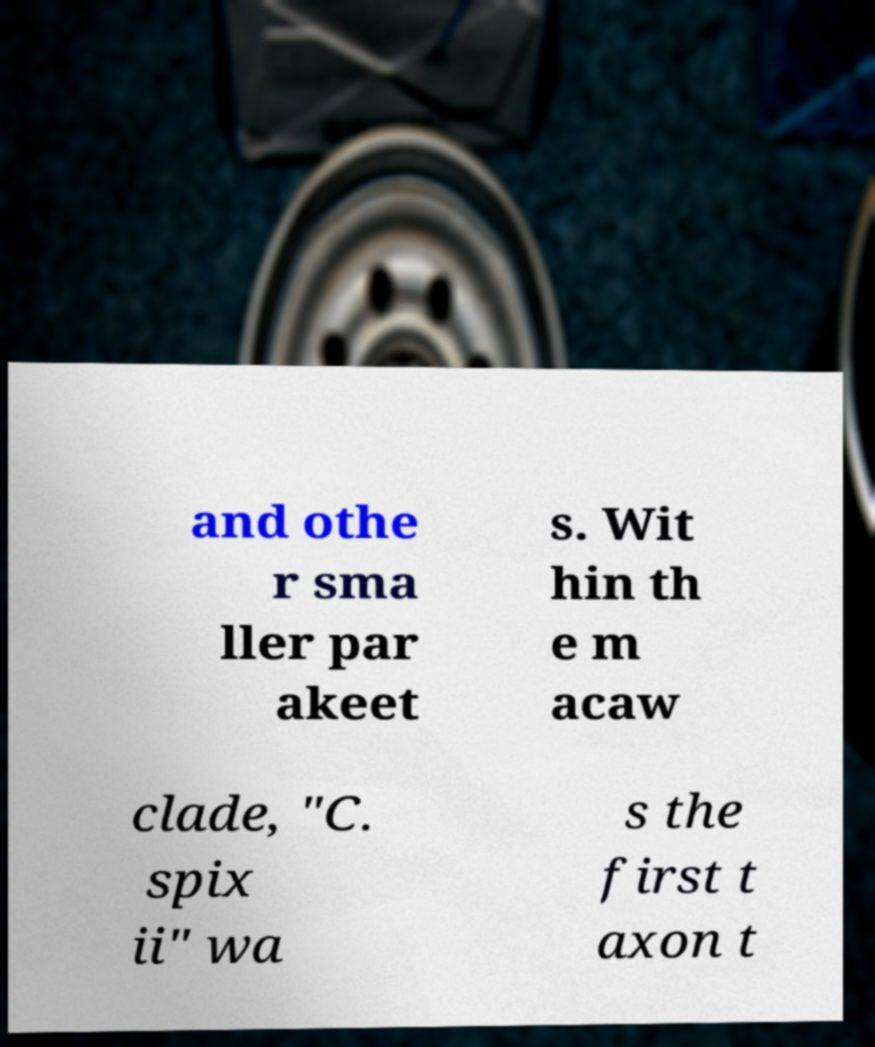I need the written content from this picture converted into text. Can you do that? and othe r sma ller par akeet s. Wit hin th e m acaw clade, "C. spix ii" wa s the first t axon t 